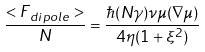Convert formula to latex. <formula><loc_0><loc_0><loc_500><loc_500>\frac { < { F } { _ { d i p o l e } } > } { N } = \frac { \hbar { ( } N \gamma ) \nu \mu ( \nabla \mu ) } { 4 \eta ( 1 + \xi ^ { 2 } ) }</formula> 